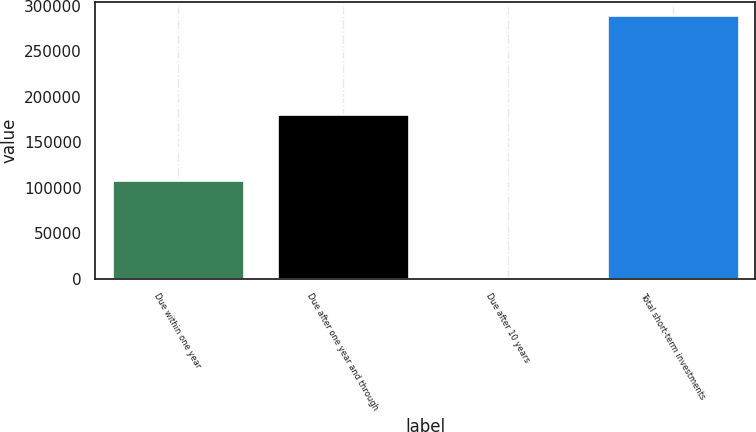Convert chart. <chart><loc_0><loc_0><loc_500><loc_500><bar_chart><fcel>Due within one year<fcel>Due after one year and through<fcel>Due after 10 years<fcel>Total short-term investments<nl><fcel>108382<fcel>180373<fcel>1003<fcel>289758<nl></chart> 